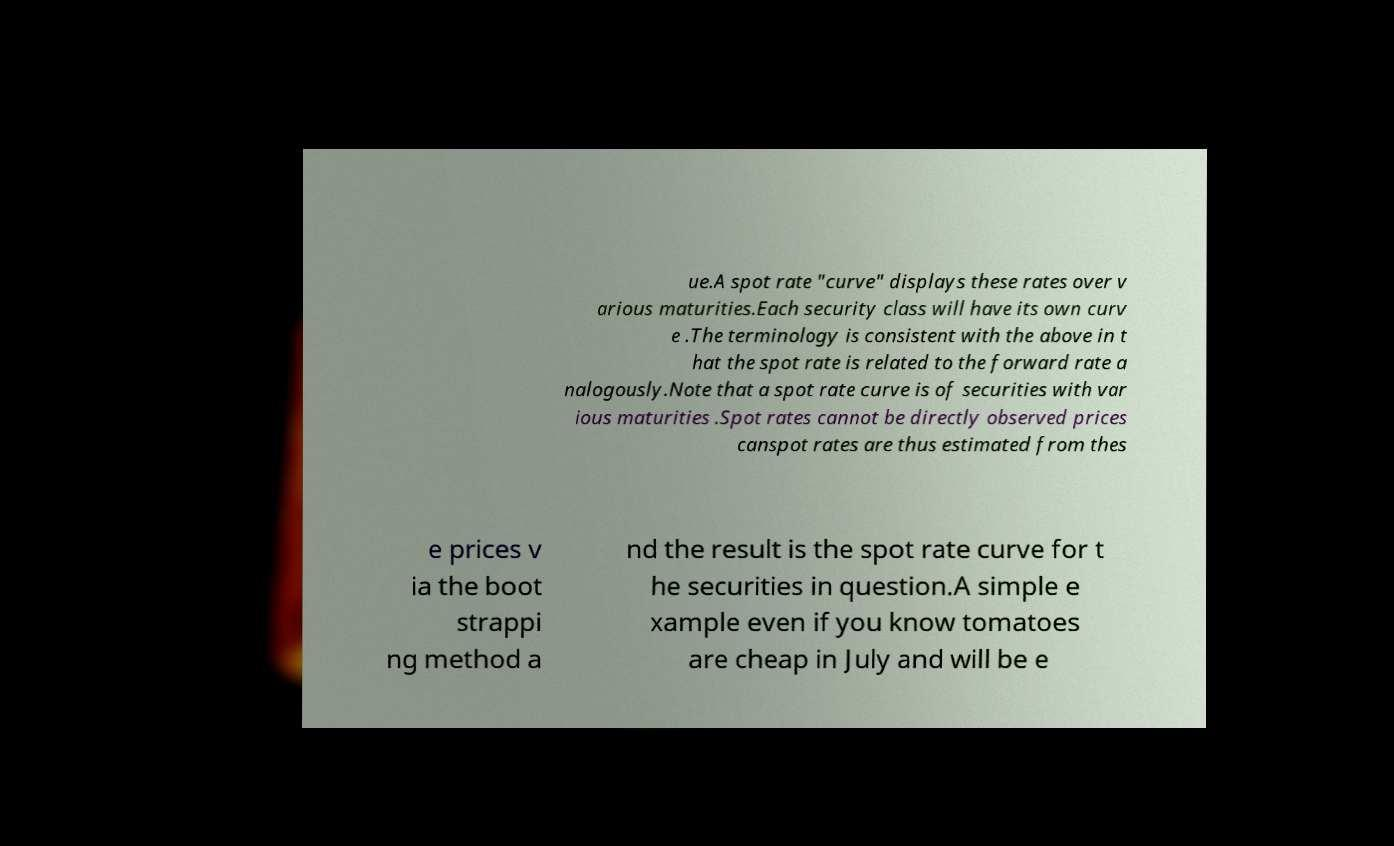For documentation purposes, I need the text within this image transcribed. Could you provide that? ue.A spot rate "curve" displays these rates over v arious maturities.Each security class will have its own curv e .The terminology is consistent with the above in t hat the spot rate is related to the forward rate a nalogously.Note that a spot rate curve is of securities with var ious maturities .Spot rates cannot be directly observed prices canspot rates are thus estimated from thes e prices v ia the boot strappi ng method a nd the result is the spot rate curve for t he securities in question.A simple e xample even if you know tomatoes are cheap in July and will be e 